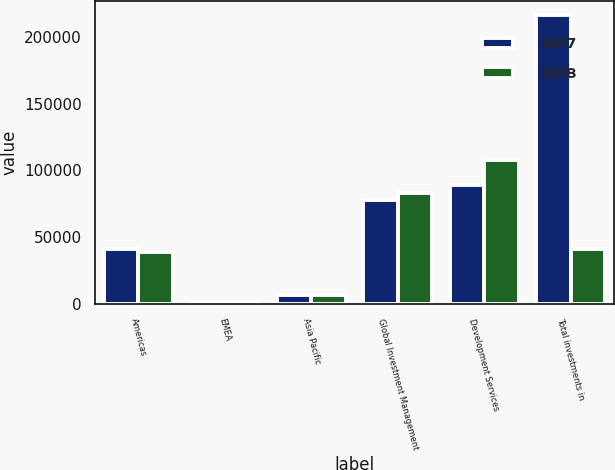<chart> <loc_0><loc_0><loc_500><loc_500><stacked_bar_chart><ecel><fcel>Americas<fcel>EMEA<fcel>Asia Pacific<fcel>Global Investment Management<fcel>Development Services<fcel>Total investments in<nl><fcel>2017<fcel>41446<fcel>864<fcel>6845<fcel>77926<fcel>89093<fcel>216174<nl><fcel>2018<fcel>39105<fcel>852<fcel>6581<fcel>83430<fcel>108033<fcel>41446<nl></chart> 